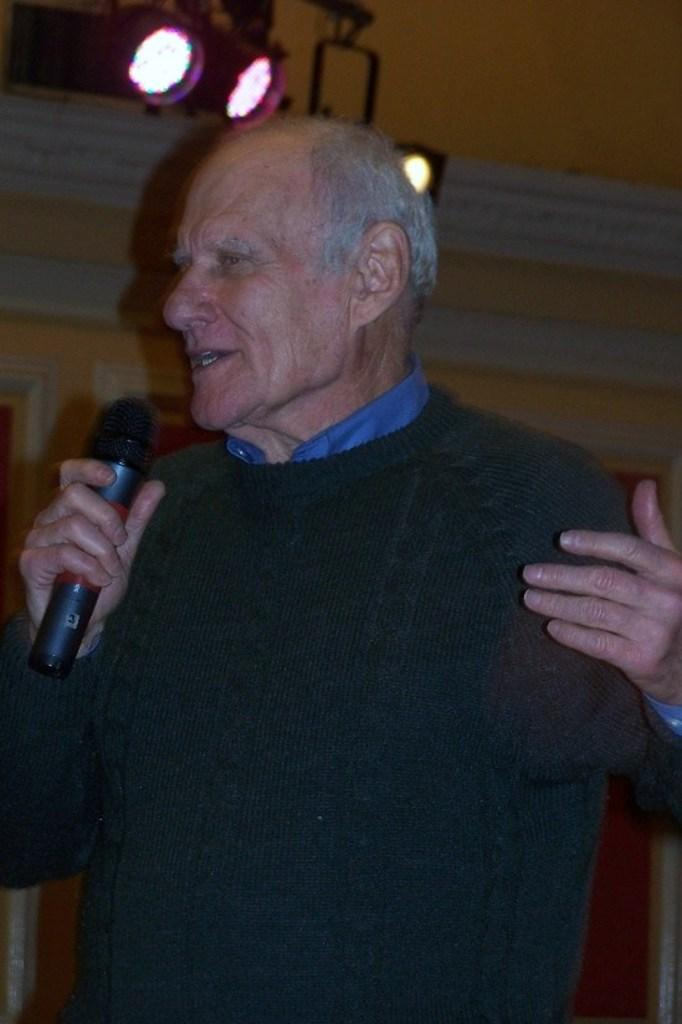What is happening in the image? There is a person in the image who is singing a song. What object is the person holding while singing? The person is holding a microphone in his hand. What type of nail is the person hammering in the image? There is no nail present in the image; the person is holding a microphone while singing. 